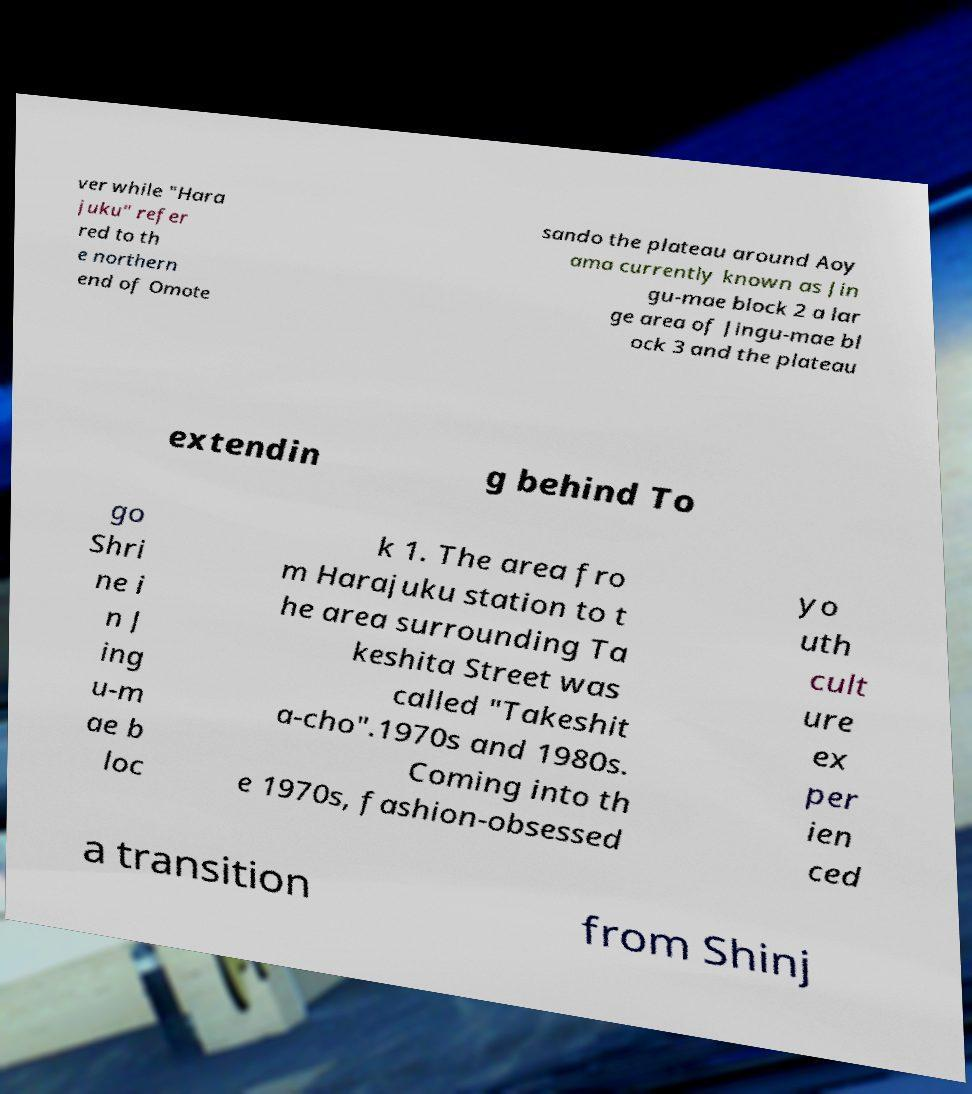Please read and relay the text visible in this image. What does it say? ver while "Hara juku" refer red to th e northern end of Omote sando the plateau around Aoy ama currently known as Jin gu-mae block 2 a lar ge area of Jingu-mae bl ock 3 and the plateau extendin g behind To go Shri ne i n J ing u-m ae b loc k 1. The area fro m Harajuku station to t he area surrounding Ta keshita Street was called "Takeshit a-cho".1970s and 1980s. Coming into th e 1970s, fashion-obsessed yo uth cult ure ex per ien ced a transition from Shinj 